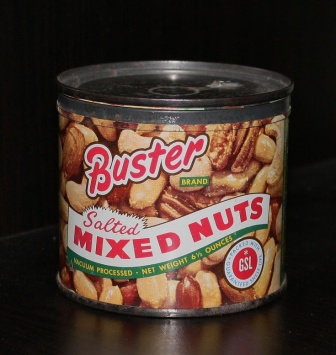 This image displays a can of Buster Brand Salted Mixed Nuts, featuring a vibrant label that highlights the variety of nuts inside. The can is placed on a dark wooden surface, adding a rustic and cozy feel to the presentation. What types of nuts are shown on the label? The label on the can features an assortment of nuts, including pecans, almonds, and cashews. Their images are prominently displayed on the label, suggesting a diverse and delicious mix inside the can. Can you describe the color scheme and design of the label? The label of the Buster Brand Salted Mixed Nuts can is vibrant and eye-catching. It primarily uses red, white, and yellow colors, which create a cheerful and appetizing appeal. The text is written in bold red and white letters for the brand name and product description. The inclusion of the nuts’ imagery against the label's background provides an inviting and appealing look. 